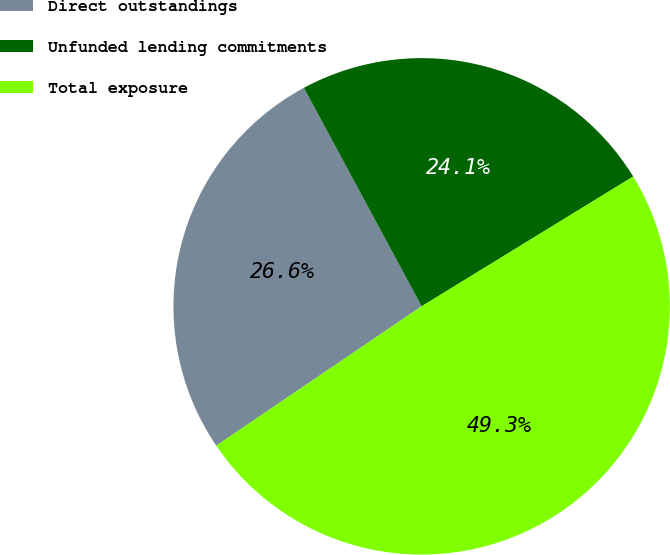Convert chart to OTSL. <chart><loc_0><loc_0><loc_500><loc_500><pie_chart><fcel>Direct outstandings<fcel>Unfunded lending commitments<fcel>Total exposure<nl><fcel>26.62%<fcel>24.11%<fcel>49.27%<nl></chart> 